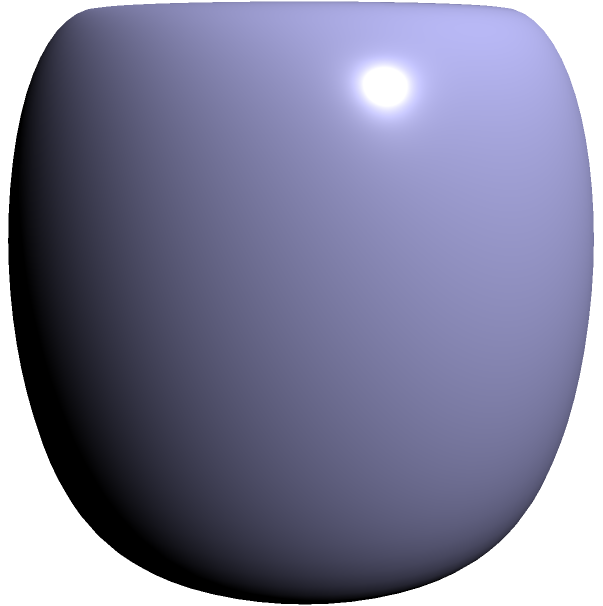In the spirit of Tom Waits' eclectic musical style, consider a surface created by interconnecting various musical instruments. The resulting shape resembles a torus with three points on its surface connected to form a triangle, as shown in the diagram. What is the genus of this modified surface? To determine the genus of this modified surface, let's follow these steps:

1) First, recall that a torus has a genus of 1.

2) The modification we've made is equivalent to attaching a disk to the torus along the triangular path.

3) In topology, attaching a disk to a surface along a simple closed curve is equivalent to reducing the genus by 1, if the curve is non-contractible.

4) The triangular path on the torus is non-contractible, as it can't be continuously shrunk to a point while staying on the surface.

5) Therefore, attaching the disk effectively reduces the genus of the torus by 1.

6) Since the original genus of the torus was 1, and we've reduced it by 1, the resulting genus is:

   $$1 - 1 = 0$$

7) A genus of 0 corresponds to a topological sphere.

Thus, the modified surface is topologically equivalent to a sphere.
Answer: 0 